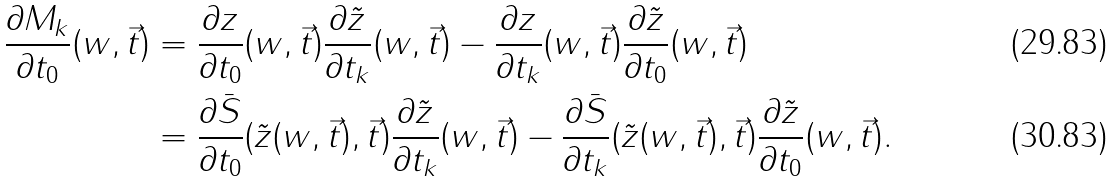Convert formula to latex. <formula><loc_0><loc_0><loc_500><loc_500>\frac { \partial M _ { k } } { \partial t _ { 0 } } ( w , \vec { t } ) & = \frac { \partial z } { \partial t _ { 0 } } ( w , \vec { t } ) \frac { \partial \tilde { z } } { \partial t _ { k } } ( w , \vec { t } ) - \frac { \partial z } { \partial t _ { k } } ( w , \vec { t } ) \frac { \partial \tilde { z } } { \partial t _ { 0 } } ( w , \vec { t } ) \\ & = \frac { \partial \bar { S } } { \partial t _ { 0 } } ( \tilde { z } ( w , \vec { t } ) , \vec { t } ) \frac { \partial \tilde { z } } { \partial t _ { k } } ( w , \vec { t } ) - \frac { \partial \bar { S } } { \partial t _ { k } } ( \tilde { z } ( w , \vec { t } ) , \vec { t } ) \frac { \partial \tilde { z } } { \partial t _ { 0 } } ( w , \vec { t } ) .</formula> 